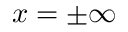Convert formula to latex. <formula><loc_0><loc_0><loc_500><loc_500>x = \pm \infty</formula> 